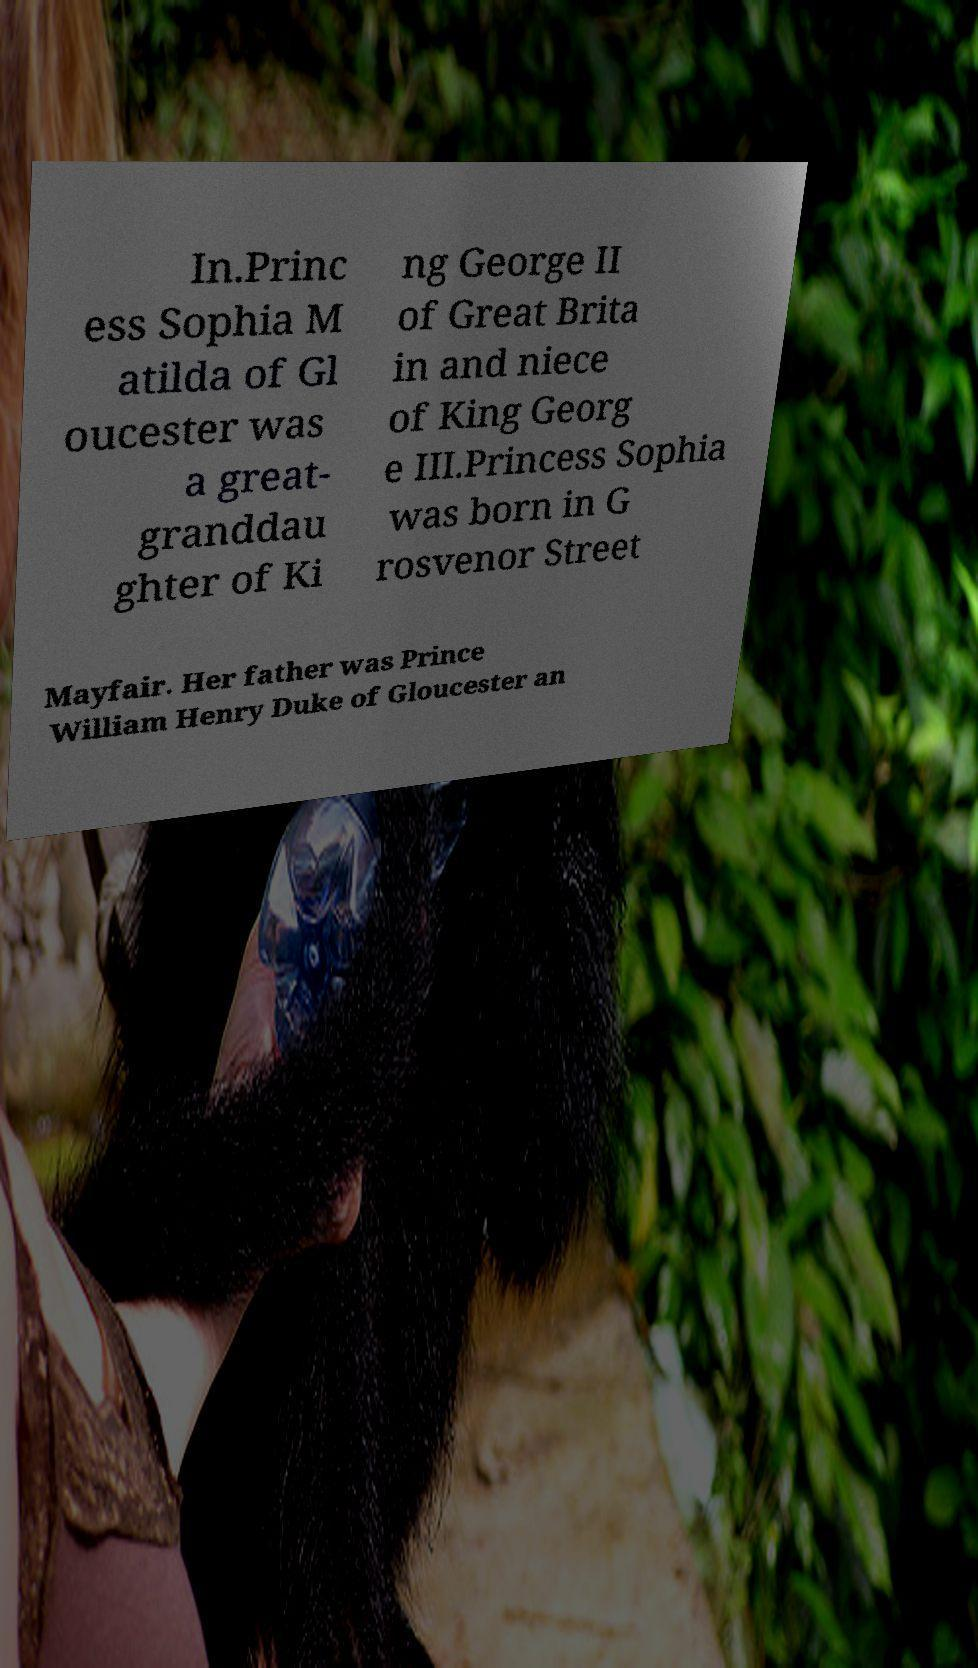I need the written content from this picture converted into text. Can you do that? In.Princ ess Sophia M atilda of Gl oucester was a great- granddau ghter of Ki ng George II of Great Brita in and niece of King Georg e III.Princess Sophia was born in G rosvenor Street Mayfair. Her father was Prince William Henry Duke of Gloucester an 